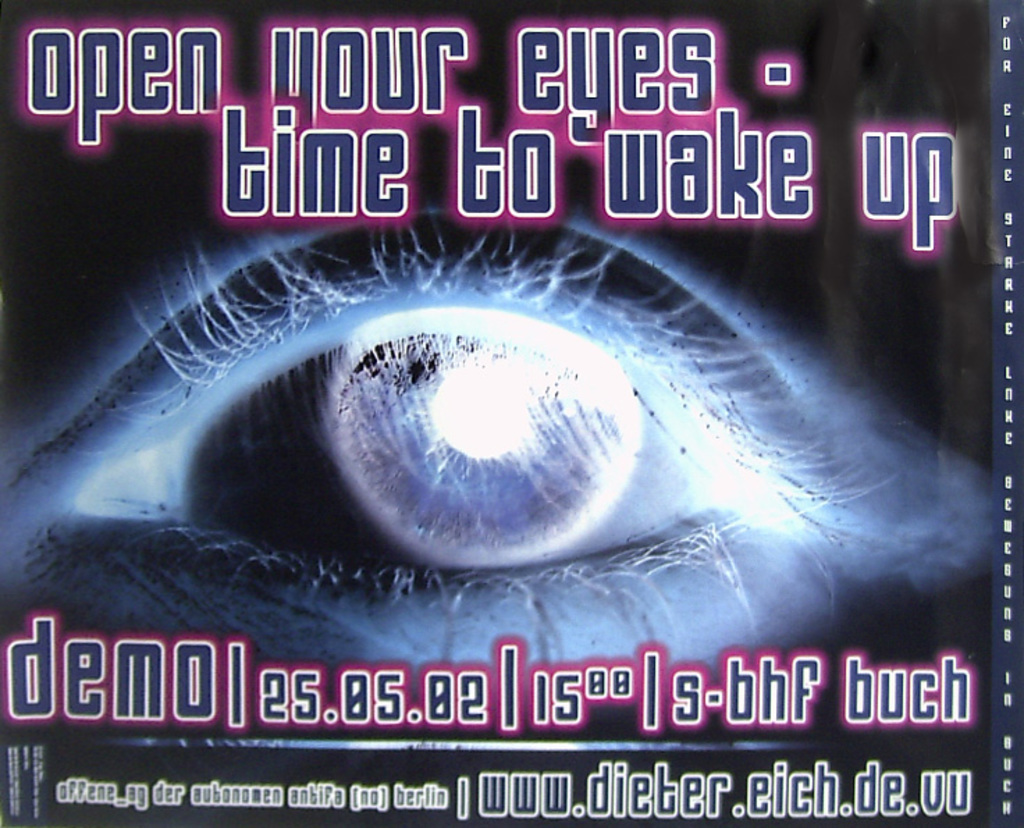What does the eye symbol in the center of the image represent? The eye, often a symbol of perception and understanding in visual arts, likely represents insight or enlightenment in this context. By placing it centrally and prominently, the poster suggests that the book may delve into themes where seeing things clearly or true understanding is key, possibly challenging the reader to reconsider their perspectives or awaken to new realities. 